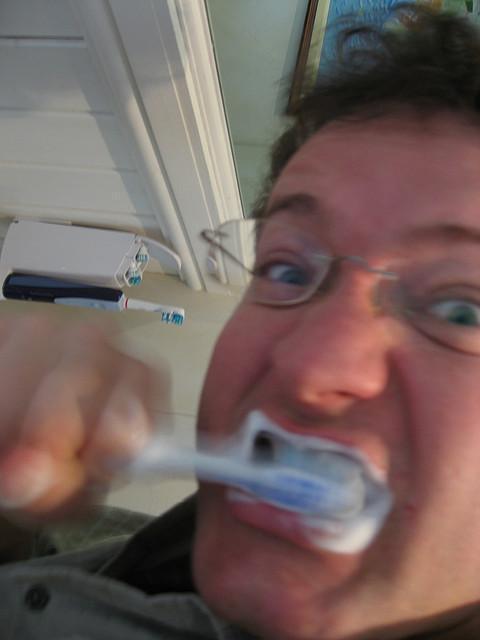How many toothbrushes can you see?
Give a very brief answer. 2. How many people is the elephant interacting with?
Give a very brief answer. 0. 